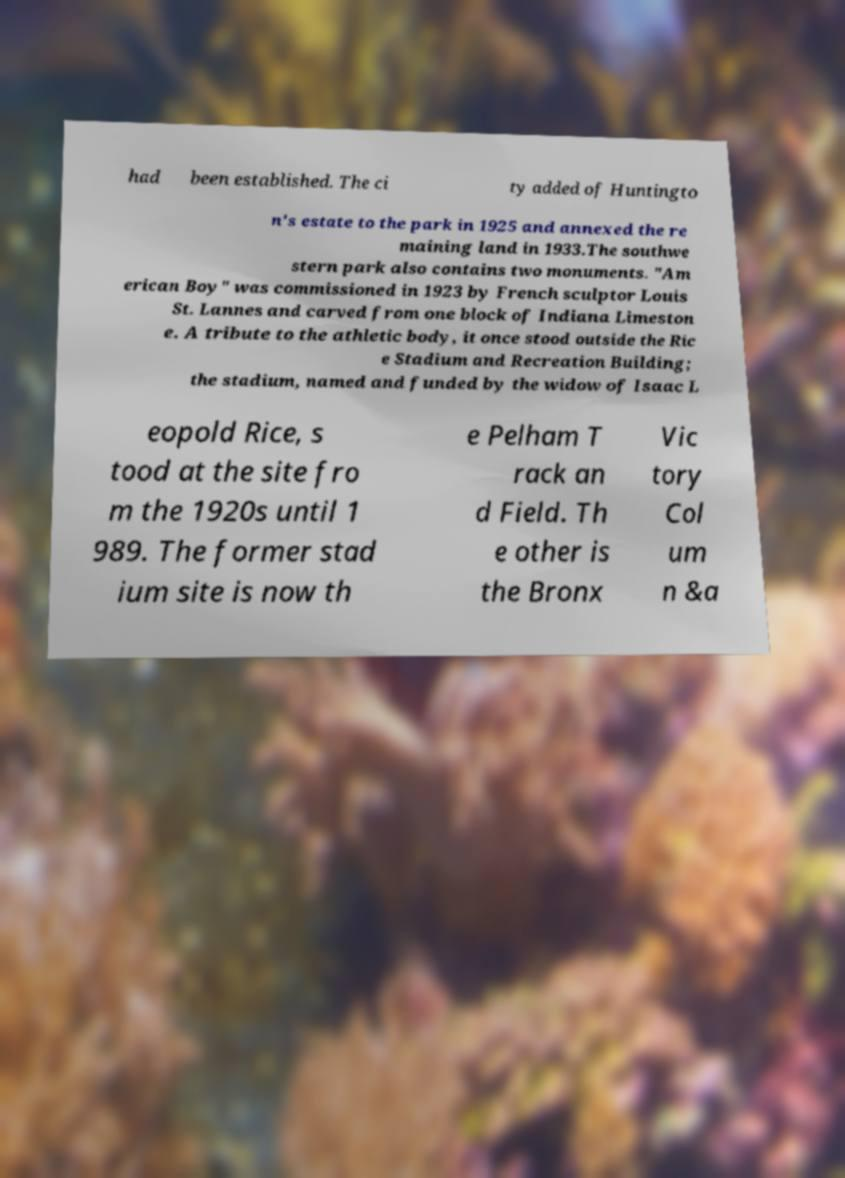There's text embedded in this image that I need extracted. Can you transcribe it verbatim? had been established. The ci ty added of Huntingto n's estate to the park in 1925 and annexed the re maining land in 1933.The southwe stern park also contains two monuments. "Am erican Boy" was commissioned in 1923 by French sculptor Louis St. Lannes and carved from one block of Indiana Limeston e. A tribute to the athletic body, it once stood outside the Ric e Stadium and Recreation Building; the stadium, named and funded by the widow of Isaac L eopold Rice, s tood at the site fro m the 1920s until 1 989. The former stad ium site is now th e Pelham T rack an d Field. Th e other is the Bronx Vic tory Col um n &a 